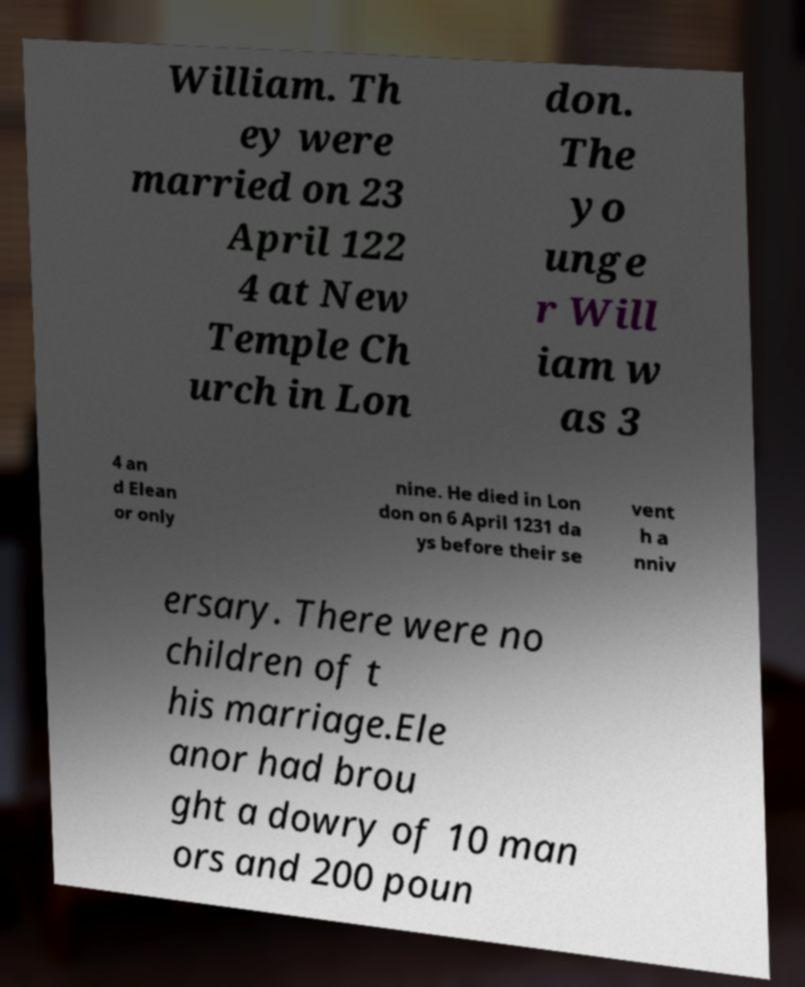Can you read and provide the text displayed in the image?This photo seems to have some interesting text. Can you extract and type it out for me? William. Th ey were married on 23 April 122 4 at New Temple Ch urch in Lon don. The yo unge r Will iam w as 3 4 an d Elean or only nine. He died in Lon don on 6 April 1231 da ys before their se vent h a nniv ersary. There were no children of t his marriage.Ele anor had brou ght a dowry of 10 man ors and 200 poun 